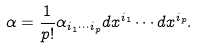<formula> <loc_0><loc_0><loc_500><loc_500>\alpha = { \frac { 1 } { p ! } } \alpha _ { i _ { 1 } \cdots i _ { p } } d x ^ { i _ { 1 } } \cdots d x ^ { i _ { p } } .</formula> 